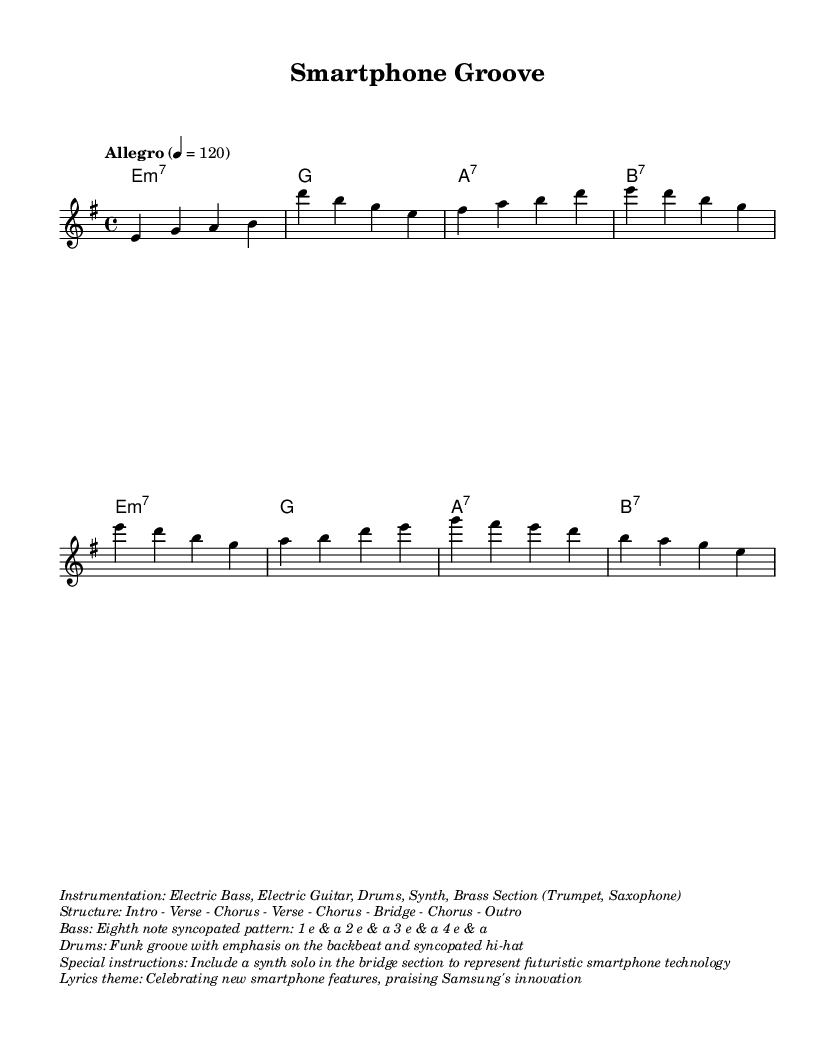What is the key signature of this music? The key signature is E minor, indicated by the one sharp (F#) in the sheet music.
Answer: E minor What is the time signature of this music? The time signature is 4/4, shown at the beginning of the score in the time signature notation.
Answer: 4/4 What is the tempo marking for this piece? The tempo marking is "Allegro" with a tempo of 120 beats per minute, specified at the beginning of the score.
Answer: Allegro What instruments are included in the instrumentation? The instrumentation consists of Electric Bass, Electric Guitar, Drums, Synth, and a Brass Section (Trumpet, Saxophone), as indicated in the score's markup.
Answer: Electric Bass, Electric Guitar, Drums, Synth, Brass Section Describe the structure of the music. The structure is outlined in the score, detailing the order as Intro - Verse - Chorus - Verse - Chorus - Bridge - Chorus - Outro.
Answer: Intro - Verse - Chorus - Verse - Chorus - Bridge - Chorus - Outro What type of rhythm pattern does the bass play? The bass plays an eighth-note syncopated pattern specified in the markup as "1 e & a 2 e & a 3 e & a 4 e & a."
Answer: Eighth note syncopated pattern What theme do the lyrics celebrate? The lyrics theme focuses on celebrating new smartphone features and praising Samsung's innovation, clearly stated in the markup section.
Answer: Celebrating new smartphone features, praising Samsung's innovation 